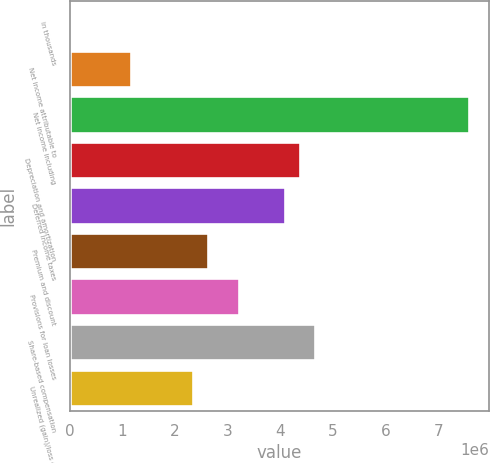Convert chart to OTSL. <chart><loc_0><loc_0><loc_500><loc_500><bar_chart><fcel>in thousands<fcel>Net income attributable to<fcel>Net income including<fcel>Depreciation and amortization<fcel>Deferred income taxes<fcel>Premium and discount<fcel>Provisions for loan losses<fcel>Share-based compensation<fcel>Unrealized (gain)/loss on<nl><fcel>2016<fcel>1.16837e+06<fcel>7.58332e+06<fcel>4.37585e+06<fcel>4.08426e+06<fcel>2.62631e+06<fcel>3.20949e+06<fcel>4.66744e+06<fcel>2.33473e+06<nl></chart> 